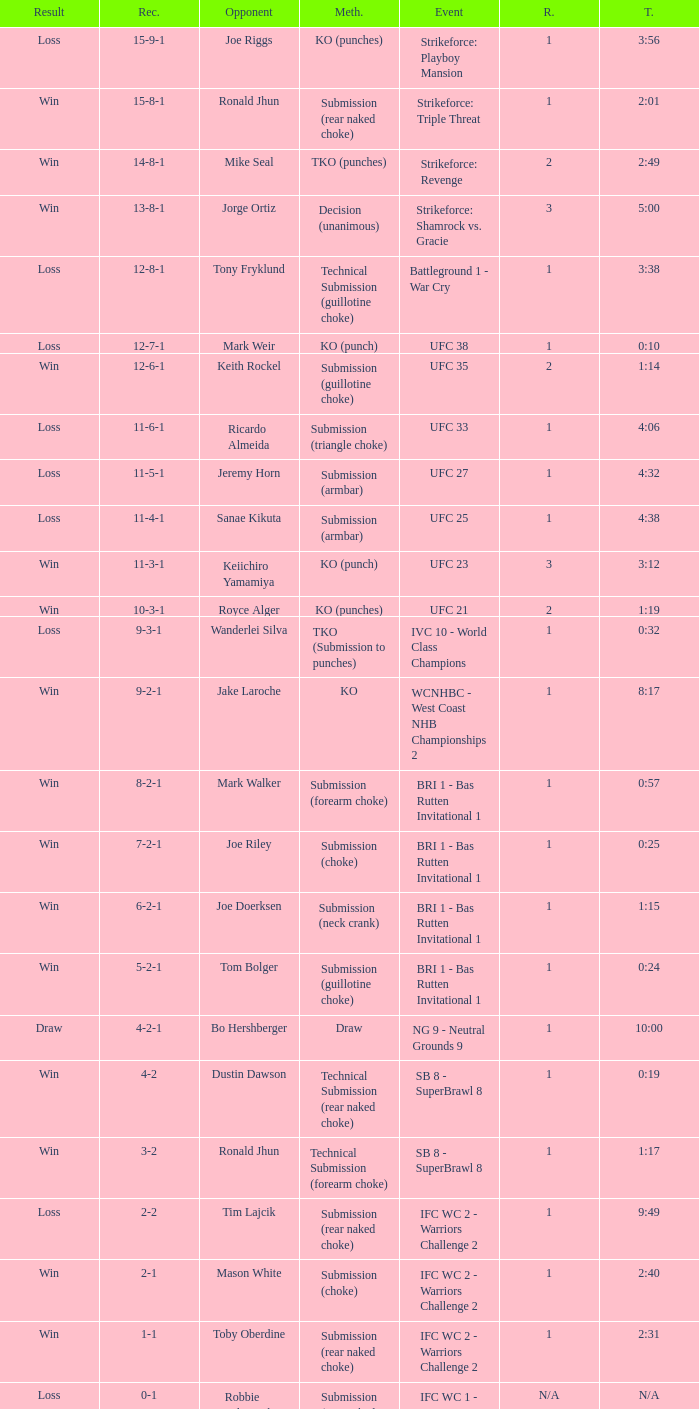Who faced off in the contest that had a duration of 2:01? Ronald Jhun. 